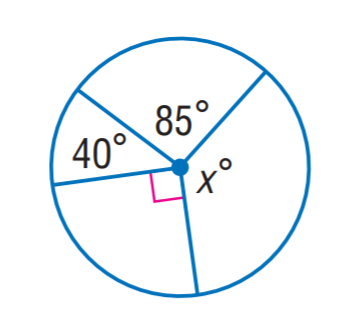Question: Find x.
Choices:
A. 95
B. 120
C. 140
D. 145
Answer with the letter. Answer: D 